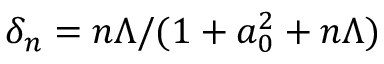<formula> <loc_0><loc_0><loc_500><loc_500>\delta _ { n } = n \Lambda / ( 1 + a _ { 0 } ^ { 2 } + n \Lambda )</formula> 